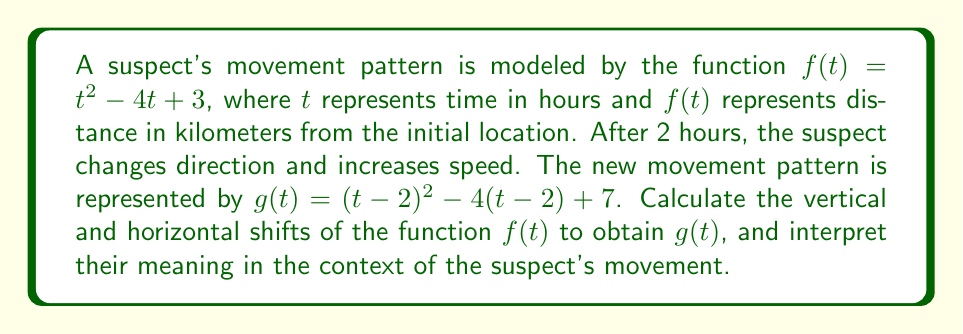Could you help me with this problem? To find the vertical and horizontal shifts, we'll compare $g(t)$ to the general form of a vertically and horizontally shifted function:

$g(t) = f(t-h) + k$

where $h$ represents the horizontal shift and $k$ represents the vertical shift.

Step 1: Expand $g(t)$
$g(t) = (t-2)^2 - 4(t-2) + 7$
$g(t) = t^2 - 4t + 4 - 4t + 8 + 7$
$g(t) = t^2 - 8t + 19$

Step 2: Compare $g(t)$ to $f(t-h) + k$
$f(t-h) + k = (t-h)^2 - 4(t-h) + 3 + k$
$f(t-h) + k = t^2 - 2ht + h^2 - 4t + 4h + 3 + k$
$f(t-h) + k = t^2 - (2h+4)t + (h^2 + 4h + 3 + k)$

Step 3: Equate coefficients of $g(t)$ and $f(t-h) + k$
$-8 = -(2h+4)$
$2h+4 = 8$
$2h = 4$
$h = 2$

$19 = h^2 + 4h + 3 + k$
$19 = 2^2 + 4(2) + 3 + k$
$19 = 4 + 8 + 3 + k$
$k = 4$

Step 4: Interpret the results
Horizontal shift: $h = 2$ (positive, shift to the right)
Vertical shift: $k = 4$ (positive, shift upward)

In the context of the suspect's movement:
- The horizontal shift of 2 units to the right indicates that the suspect's new movement pattern starts 2 hours after the initial movement began.
- The vertical shift of 4 units upward suggests that the suspect is now 4 kilometers farther from the initial location compared to where they would have been following the original movement pattern.
Answer: Horizontal shift: 2 (right), Vertical shift: 4 (up) 